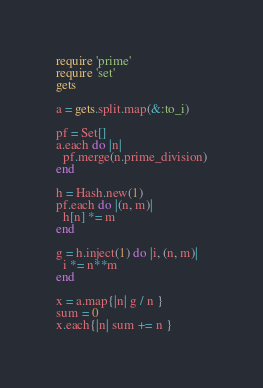Convert code to text. <code><loc_0><loc_0><loc_500><loc_500><_Ruby_>require 'prime'
require 'set'
gets

a = gets.split.map(&:to_i)

pf = Set[]
a.each do |n|
  pf.merge(n.prime_division)
end

h = Hash.new(1)
pf.each do |(n, m)|
  h[n] *= m
end

g = h.inject(1) do |i, (n, m)|
  i *= n**m
end

x = a.map{|n| g / n }
sum = 0
x.each{|n| sum += n }</code> 